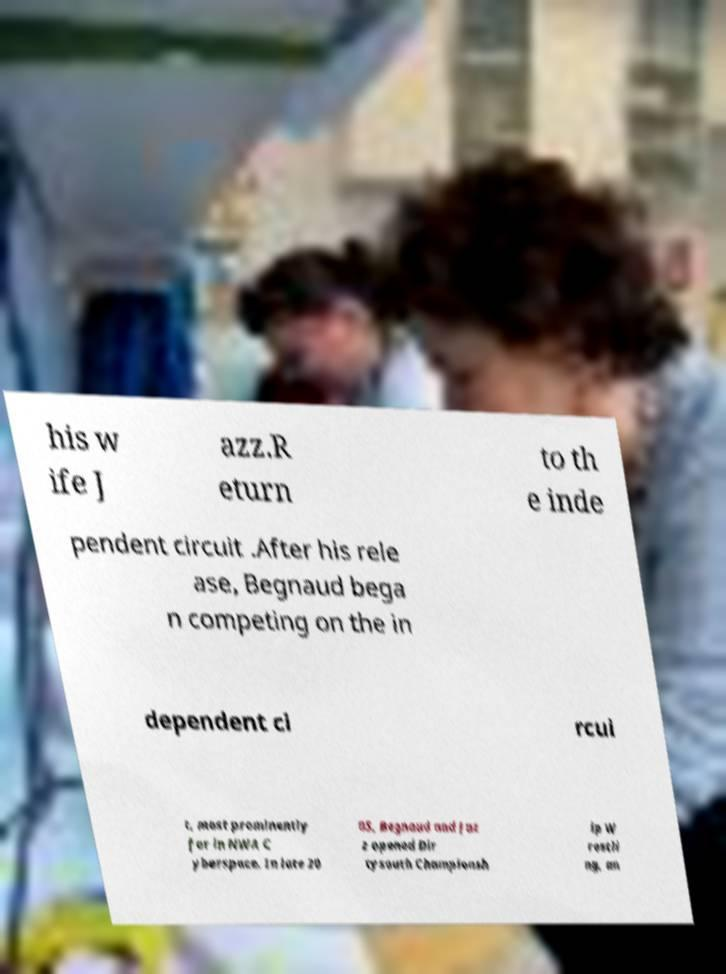Could you extract and type out the text from this image? his w ife J azz.R eturn to th e inde pendent circuit .After his rele ase, Begnaud bega n competing on the in dependent ci rcui t, most prominently for in NWA C yberspace. In late 20 05, Begnaud and Jaz z opened Dir tysouth Championsh ip W restli ng, an 